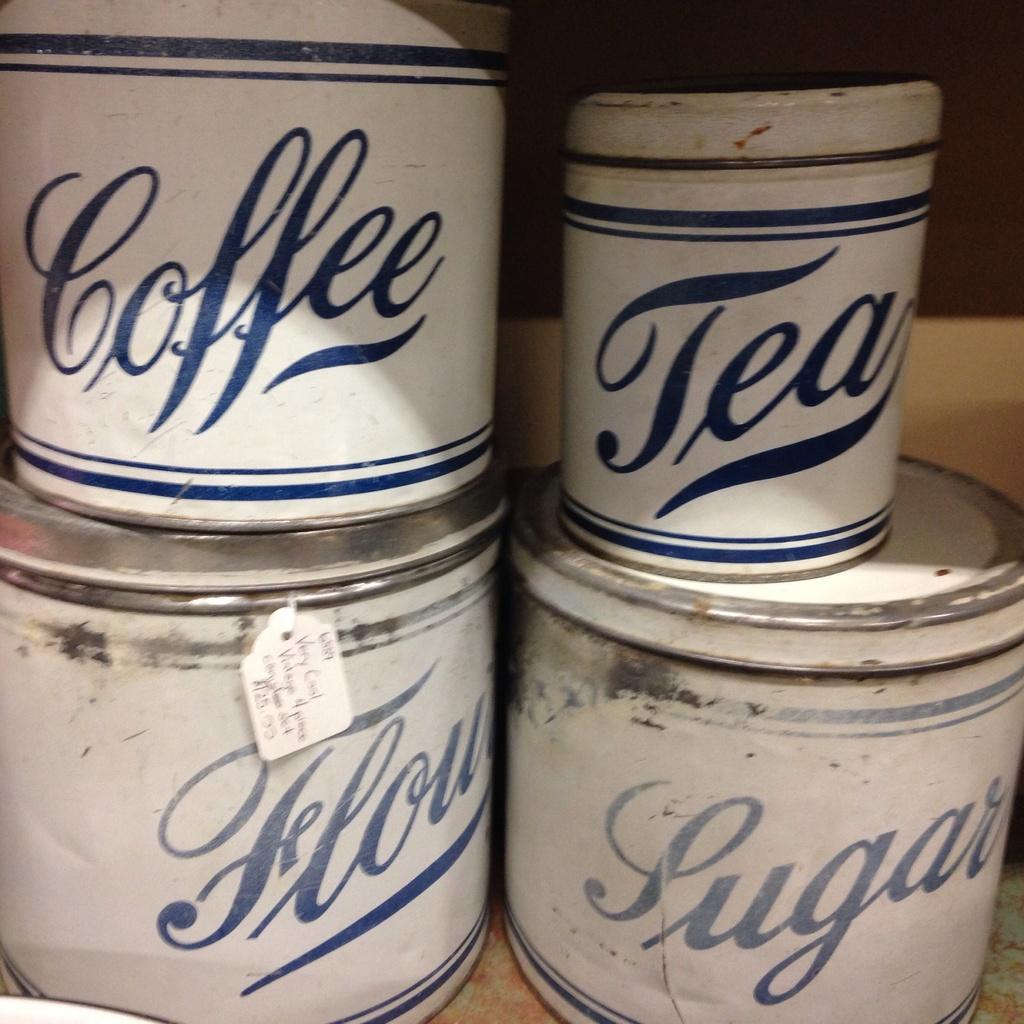<image>
Offer a succinct explanation of the picture presented. Several different cans stacked up that say things like Coffee and Tea. 